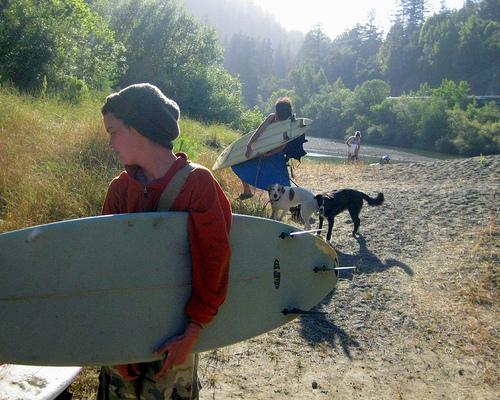How many dogs are there?
Write a very short answer. 2. Is someone wearing a hat?
Short answer required. Yes. Are the dogs going to surf?
Short answer required. No. 